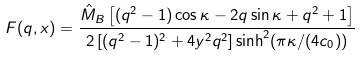Convert formula to latex. <formula><loc_0><loc_0><loc_500><loc_500>F ( q , x ) = \frac { { \hat { M } } _ { B } \left [ ( q ^ { 2 } - 1 ) \cos \kappa - 2 q \sin \kappa + q ^ { 2 } + 1 \right ] } { 2 \left [ ( q ^ { 2 } - 1 ) ^ { 2 } + 4 y ^ { 2 } q ^ { 2 } \right ] \sinh ^ { 2 } ( \pi \kappa / ( 4 c _ { 0 } ) ) }</formula> 